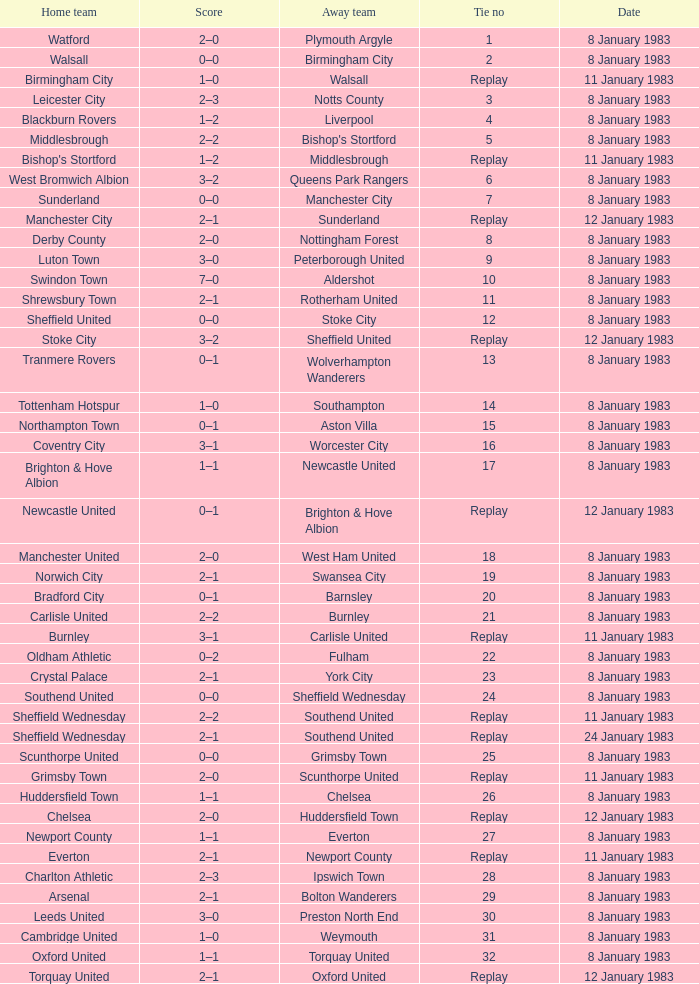For which tie was Scunthorpe United the away team? Replay. 